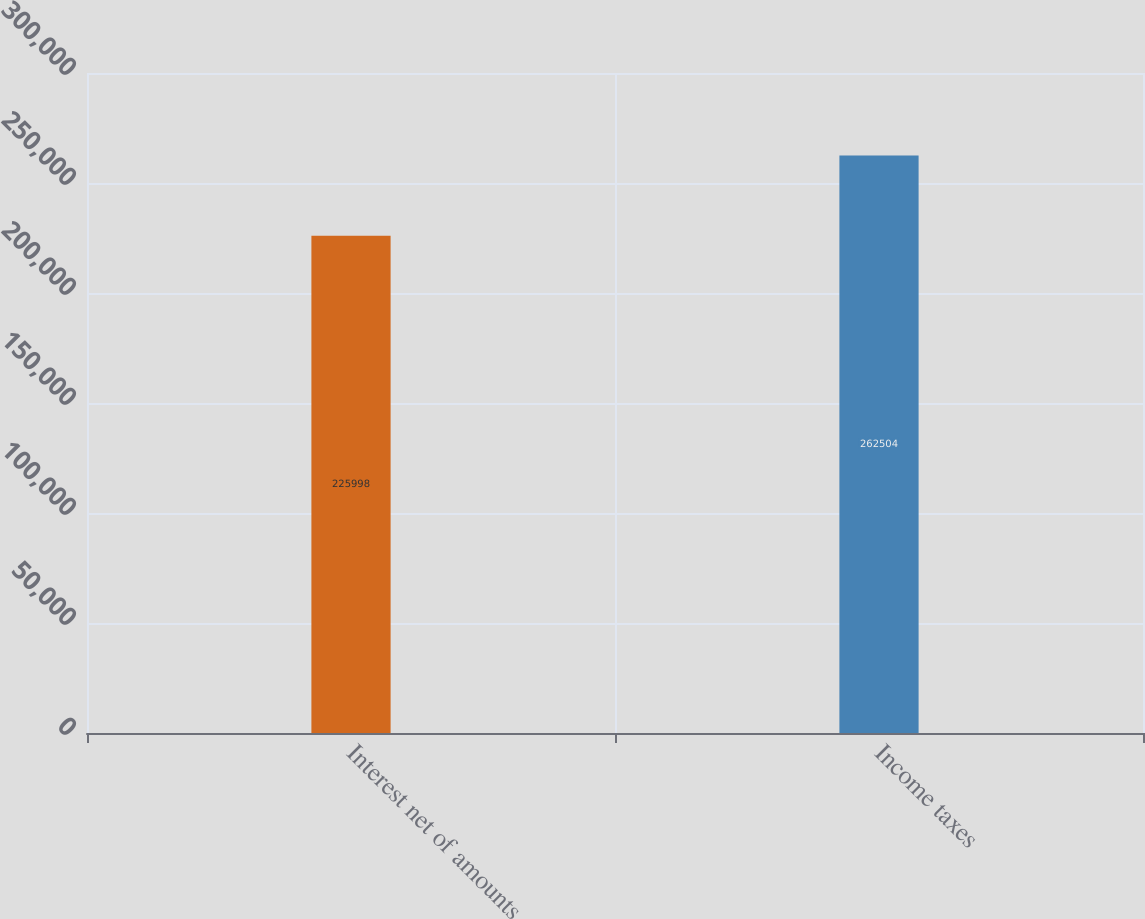<chart> <loc_0><loc_0><loc_500><loc_500><bar_chart><fcel>Interest net of amounts<fcel>Income taxes<nl><fcel>225998<fcel>262504<nl></chart> 